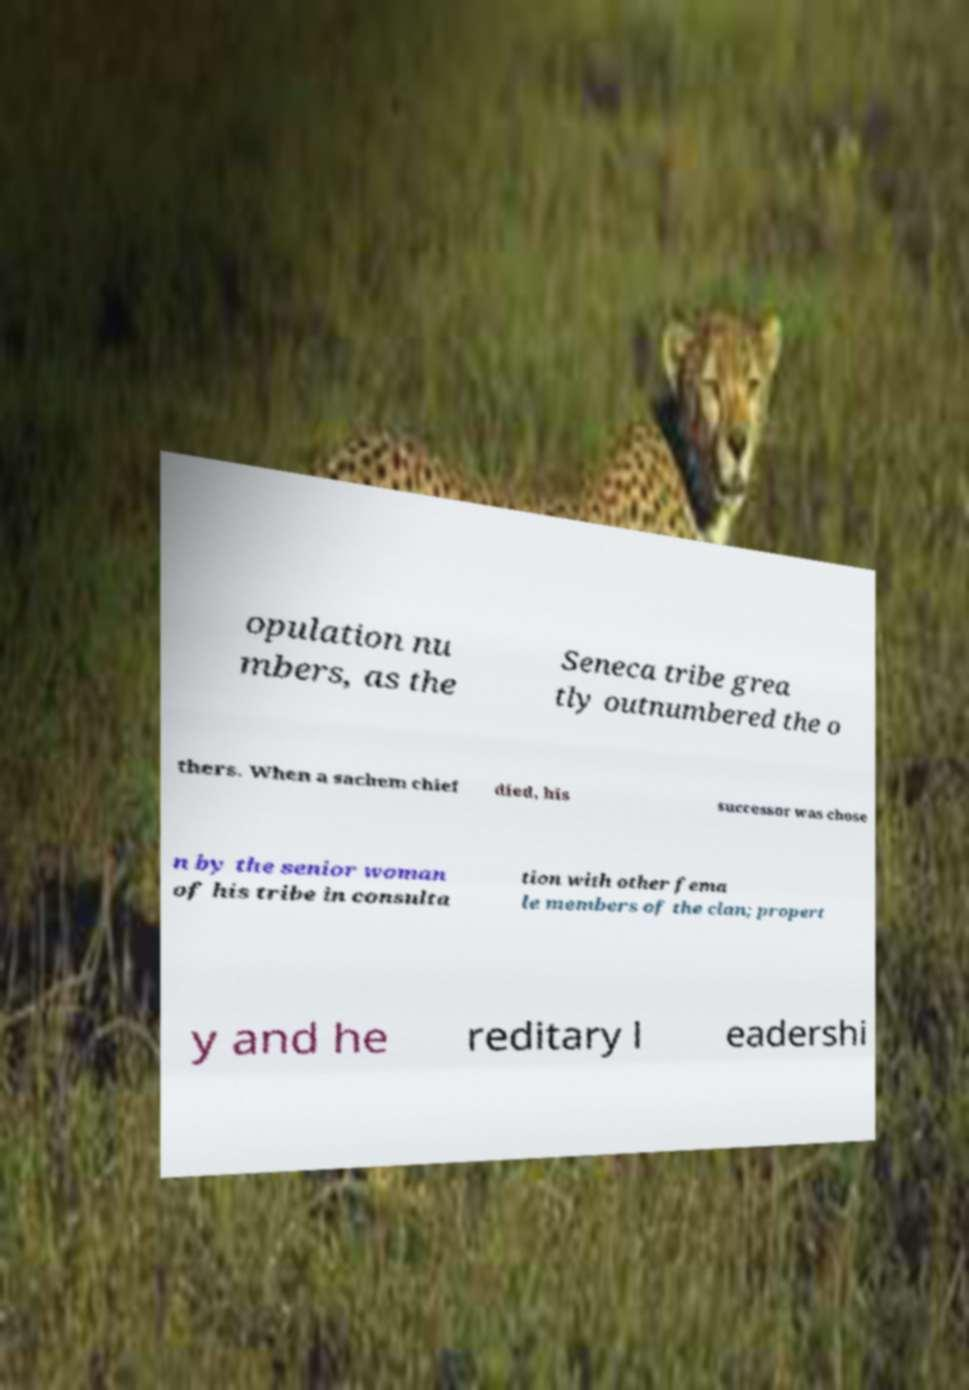For documentation purposes, I need the text within this image transcribed. Could you provide that? opulation nu mbers, as the Seneca tribe grea tly outnumbered the o thers. When a sachem chief died, his successor was chose n by the senior woman of his tribe in consulta tion with other fema le members of the clan; propert y and he reditary l eadershi 